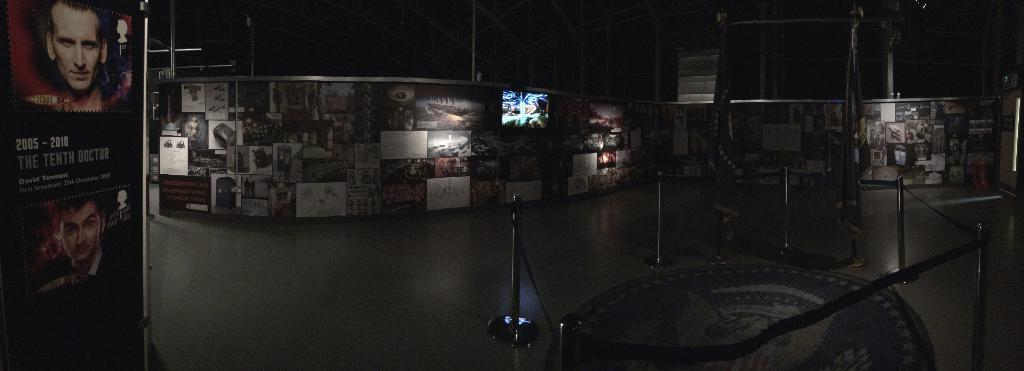At what time of day was the image taken? The image was taken at night time. Where was the image taken? The image was taken in a store. What can be seen on the walls in the image? There are banners and photographs on the walls. What is in the middle of the image? There is a fence in the middle of the image. What is located behind the fence in the image? There are flags behind the fence. What type of afterthought can be seen on the banners in the image? There is no mention of an afterthought on the banners in the image; they simply display information or images. What act is being performed by the flags in the image? The flags in the image are not performing any act; they are stationary and simply hanging behind the fence. 